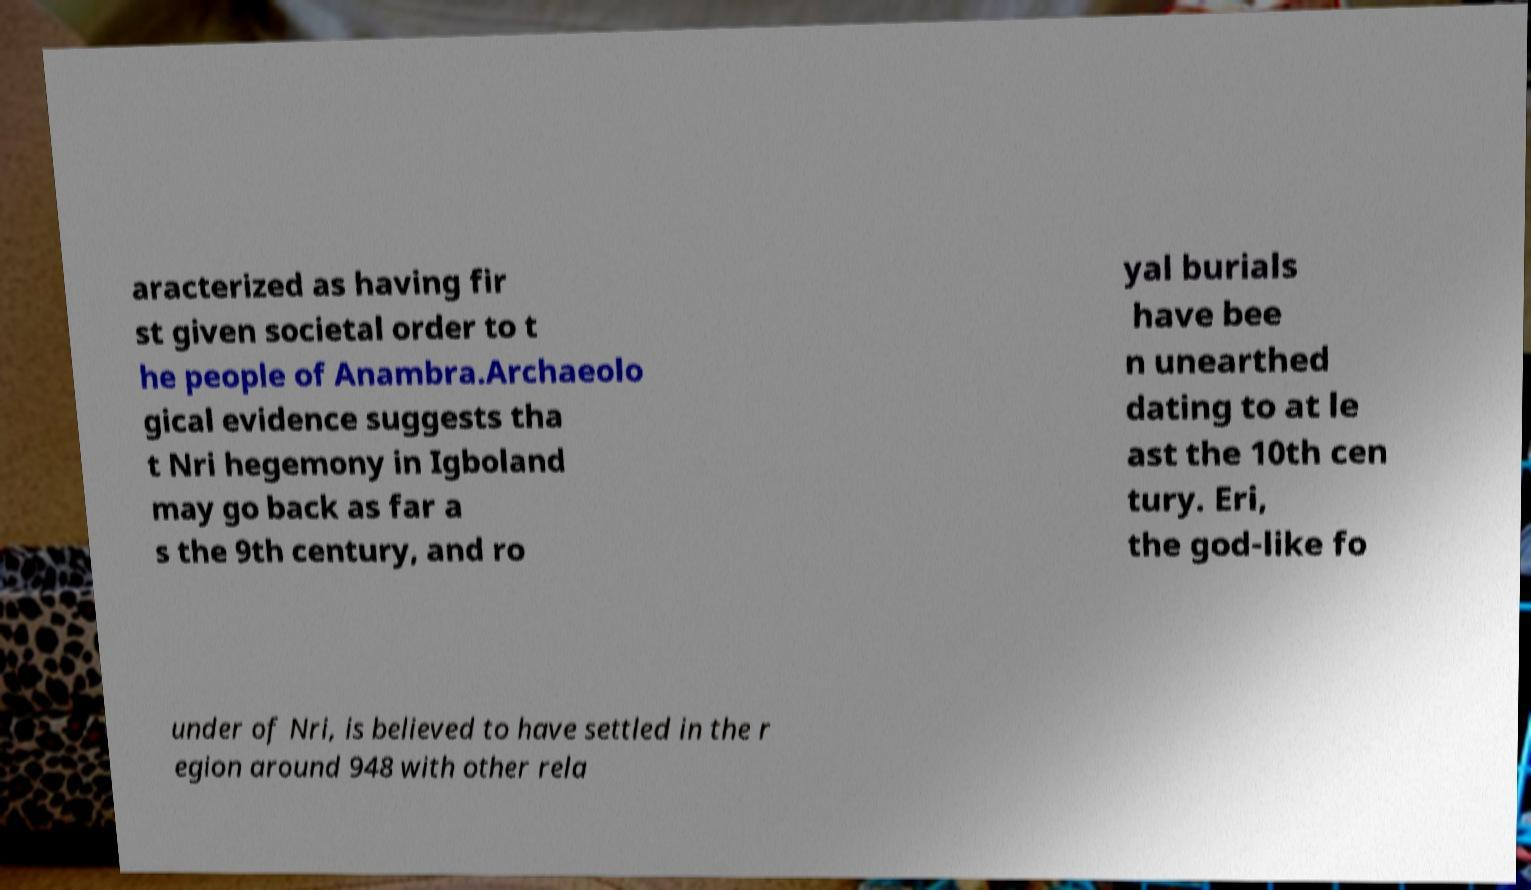Can you accurately transcribe the text from the provided image for me? aracterized as having fir st given societal order to t he people of Anambra.Archaeolo gical evidence suggests tha t Nri hegemony in Igboland may go back as far a s the 9th century, and ro yal burials have bee n unearthed dating to at le ast the 10th cen tury. Eri, the god-like fo under of Nri, is believed to have settled in the r egion around 948 with other rela 